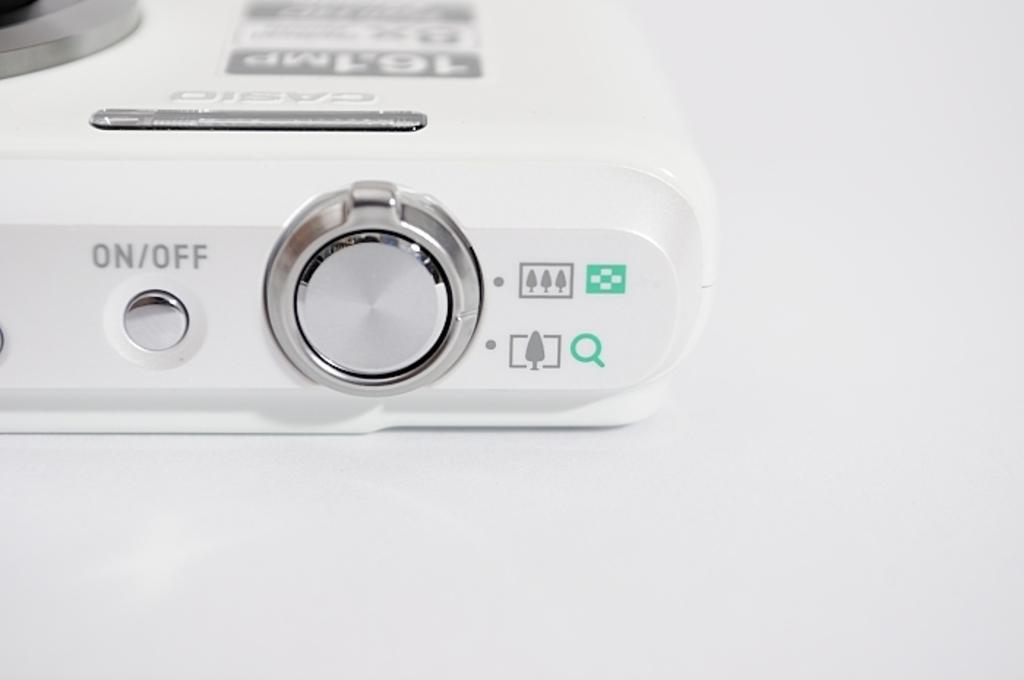<image>
Offer a succinct explanation of the picture presented. A casio camera has an on/off button on the top. 